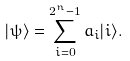<formula> <loc_0><loc_0><loc_500><loc_500>| \psi \rangle = \sum _ { i = 0 } ^ { 2 ^ { n } - 1 } a _ { i } | i \rangle .</formula> 